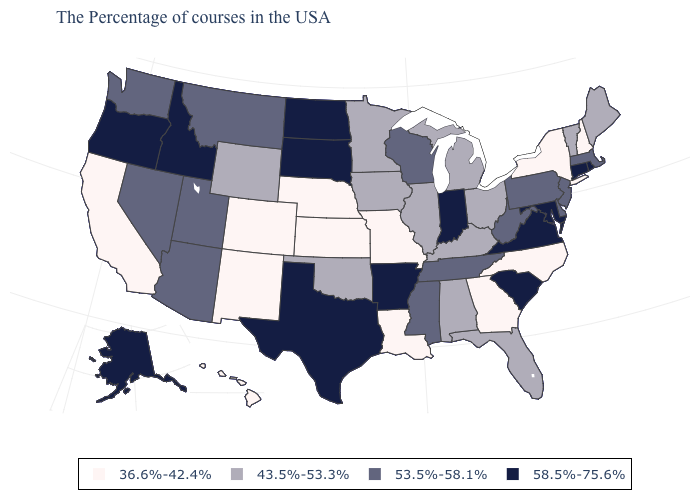Does Hawaii have the lowest value in the USA?
Write a very short answer. Yes. What is the value of Arkansas?
Give a very brief answer. 58.5%-75.6%. What is the value of Delaware?
Keep it brief. 53.5%-58.1%. Does Texas have the lowest value in the South?
Keep it brief. No. Does Michigan have a lower value than Virginia?
Keep it brief. Yes. What is the value of Alaska?
Quick response, please. 58.5%-75.6%. Which states have the lowest value in the Northeast?
Give a very brief answer. New Hampshire, New York. Which states have the highest value in the USA?
Short answer required. Rhode Island, Connecticut, Maryland, Virginia, South Carolina, Indiana, Arkansas, Texas, South Dakota, North Dakota, Idaho, Oregon, Alaska. What is the highest value in states that border Texas?
Write a very short answer. 58.5%-75.6%. What is the value of Iowa?
Write a very short answer. 43.5%-53.3%. What is the value of Washington?
Give a very brief answer. 53.5%-58.1%. How many symbols are there in the legend?
Answer briefly. 4. Is the legend a continuous bar?
Answer briefly. No. Name the states that have a value in the range 43.5%-53.3%?
Be succinct. Maine, Vermont, Ohio, Florida, Michigan, Kentucky, Alabama, Illinois, Minnesota, Iowa, Oklahoma, Wyoming. What is the lowest value in states that border Michigan?
Concise answer only. 43.5%-53.3%. 